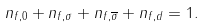Convert formula to latex. <formula><loc_0><loc_0><loc_500><loc_500>n _ { f , 0 } + n _ { f , \sigma } + n _ { f , \overline { \sigma } } + n _ { f , d } = 1 .</formula> 